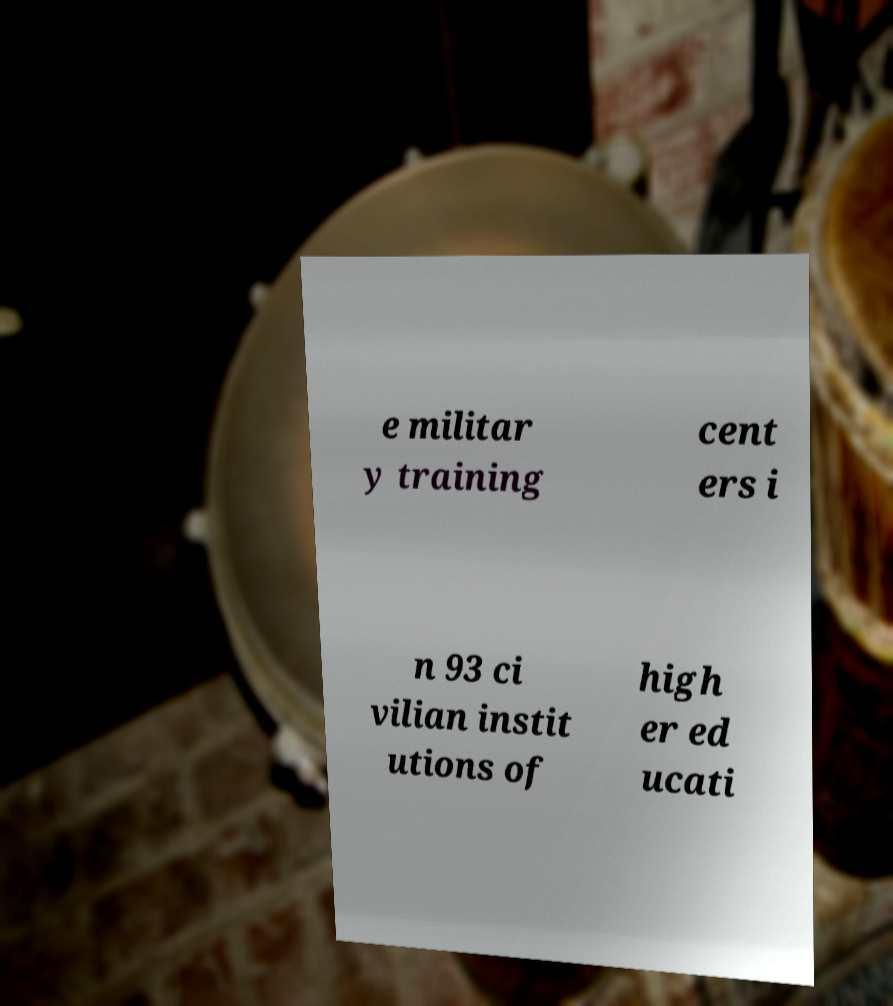Can you accurately transcribe the text from the provided image for me? e militar y training cent ers i n 93 ci vilian instit utions of high er ed ucati 